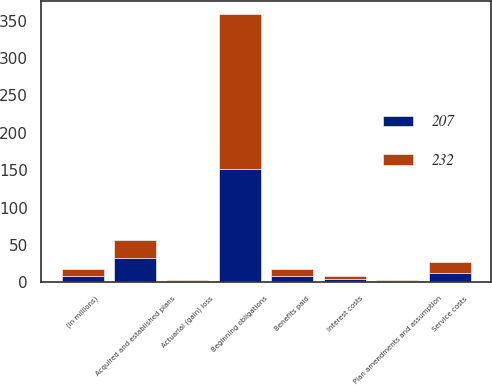<chart> <loc_0><loc_0><loc_500><loc_500><stacked_bar_chart><ecel><fcel>(in millions)<fcel>Beginning obligations<fcel>Acquired and established plans<fcel>Service costs<fcel>Interest costs<fcel>Actuarial (gain) loss<fcel>Plan amendments and assumption<fcel>Benefits paid<nl><fcel>232<fcel>9<fcel>207<fcel>23<fcel>14<fcel>4<fcel>1<fcel>2<fcel>10<nl><fcel>207<fcel>9<fcel>152<fcel>33<fcel>13<fcel>4<fcel>2<fcel>1<fcel>8<nl></chart> 